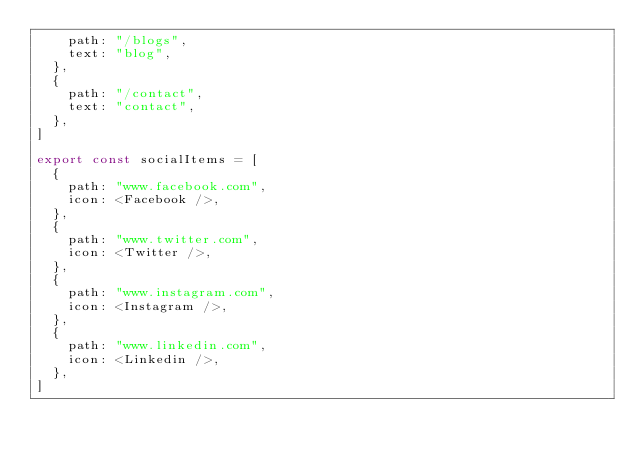<code> <loc_0><loc_0><loc_500><loc_500><_JavaScript_>    path: "/blogs",
    text: "blog",
  },
  {
    path: "/contact",
    text: "contact",
  },
]

export const socialItems = [
  {
    path: "www.facebook.com",
    icon: <Facebook />,
  },
  {
    path: "www.twitter.com",
    icon: <Twitter />,
  },
  {
    path: "www.instagram.com",
    icon: <Instagram />,
  },
  {
    path: "www.linkedin.com",
    icon: <Linkedin />,
  },
]
</code> 